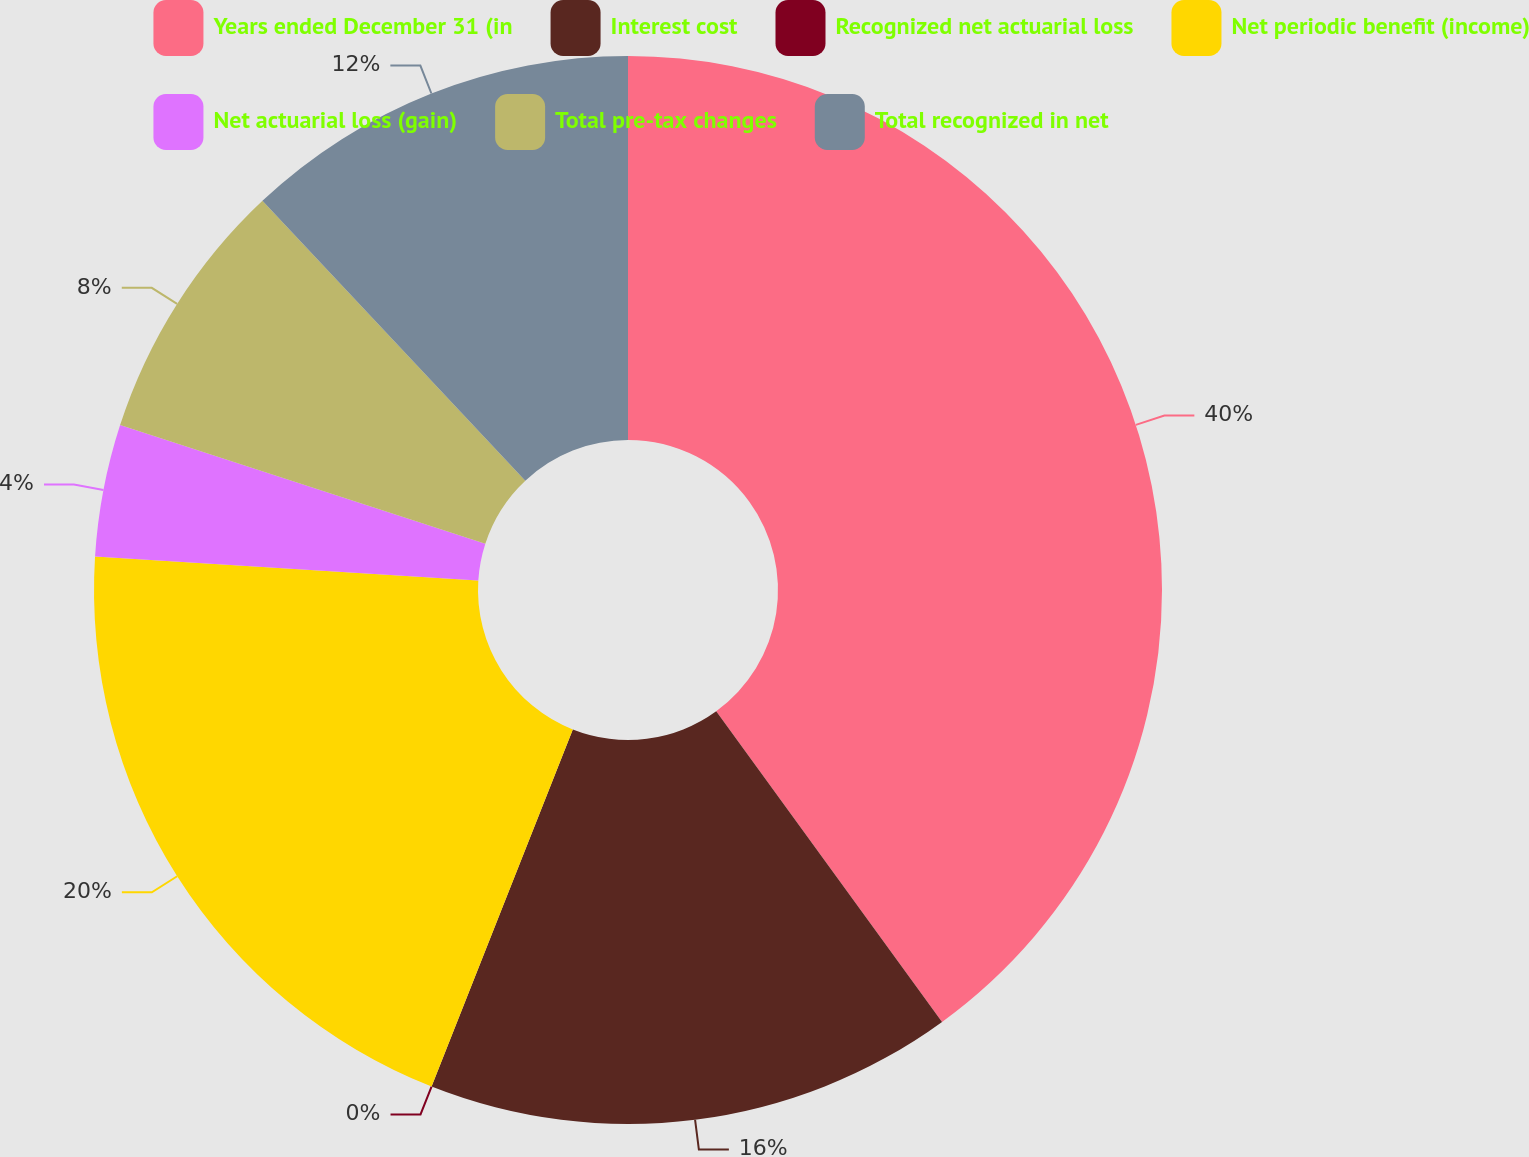Convert chart. <chart><loc_0><loc_0><loc_500><loc_500><pie_chart><fcel>Years ended December 31 (in<fcel>Interest cost<fcel>Recognized net actuarial loss<fcel>Net periodic benefit (income)<fcel>Net actuarial loss (gain)<fcel>Total pre-tax changes<fcel>Total recognized in net<nl><fcel>39.99%<fcel>16.0%<fcel>0.0%<fcel>20.0%<fcel>4.0%<fcel>8.0%<fcel>12.0%<nl></chart> 